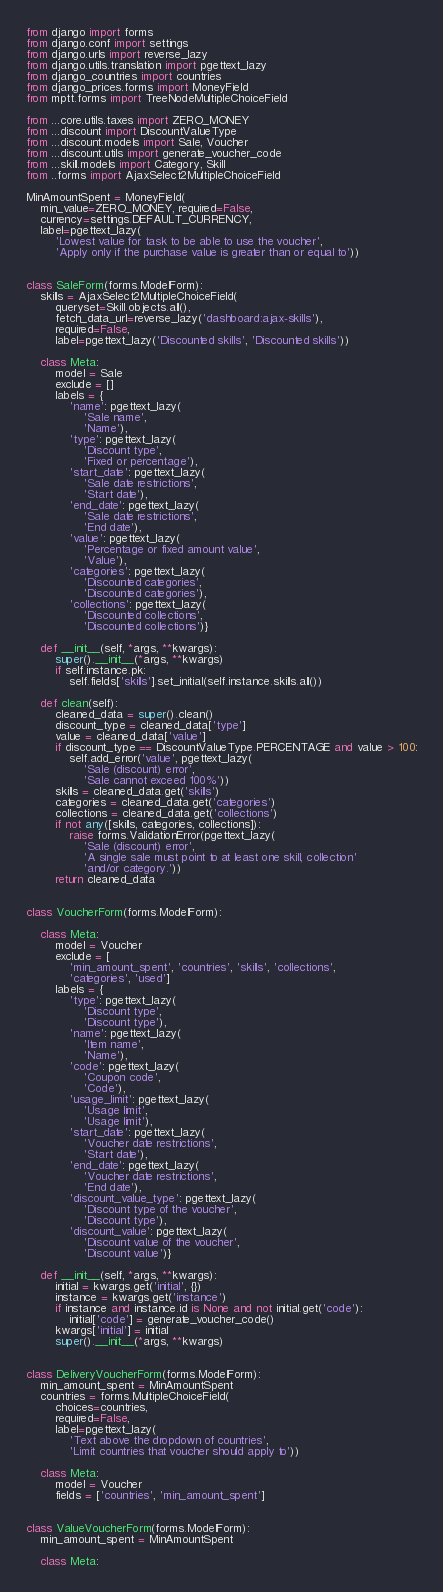Convert code to text. <code><loc_0><loc_0><loc_500><loc_500><_Python_>from django import forms
from django.conf import settings
from django.urls import reverse_lazy
from django.utils.translation import pgettext_lazy
from django_countries import countries
from django_prices.forms import MoneyField
from mptt.forms import TreeNodeMultipleChoiceField

from ...core.utils.taxes import ZERO_MONEY
from ...discount import DiscountValueType
from ...discount.models import Sale, Voucher
from ...discount.utils import generate_voucher_code
from ...skill.models import Category, Skill
from ..forms import AjaxSelect2MultipleChoiceField

MinAmountSpent = MoneyField(
    min_value=ZERO_MONEY, required=False,
    currency=settings.DEFAULT_CURRENCY,
    label=pgettext_lazy(
        'Lowest value for task to be able to use the voucher',
        'Apply only if the purchase value is greater than or equal to'))


class SaleForm(forms.ModelForm):
    skills = AjaxSelect2MultipleChoiceField(
        queryset=Skill.objects.all(),
        fetch_data_url=reverse_lazy('dashboard:ajax-skills'),
        required=False,
        label=pgettext_lazy('Discounted skills', 'Discounted skills'))

    class Meta:
        model = Sale
        exclude = []
        labels = {
            'name': pgettext_lazy(
                'Sale name',
                'Name'),
            'type': pgettext_lazy(
                'Discount type',
                'Fixed or percentage'),
            'start_date': pgettext_lazy(
                'Sale date restrictions',
                'Start date'),
            'end_date': pgettext_lazy(
                'Sale date restrictions',
                'End date'),
            'value': pgettext_lazy(
                'Percentage or fixed amount value',
                'Value'),
            'categories': pgettext_lazy(
                'Discounted categories',
                'Discounted categories'),
            'collections': pgettext_lazy(
                'Discounted collections',
                'Discounted collections')}

    def __init__(self, *args, **kwargs):
        super().__init__(*args, **kwargs)
        if self.instance.pk:
            self.fields['skills'].set_initial(self.instance.skills.all())

    def clean(self):
        cleaned_data = super().clean()
        discount_type = cleaned_data['type']
        value = cleaned_data['value']
        if discount_type == DiscountValueType.PERCENTAGE and value > 100:
            self.add_error('value', pgettext_lazy(
                'Sale (discount) error',
                'Sale cannot exceed 100%'))
        skills = cleaned_data.get('skills')
        categories = cleaned_data.get('categories')
        collections = cleaned_data.get('collections')
        if not any([skills, categories, collections]):
            raise forms.ValidationError(pgettext_lazy(
                'Sale (discount) error',
                'A single sale must point to at least one skill, collection'
                'and/or category.'))
        return cleaned_data


class VoucherForm(forms.ModelForm):

    class Meta:
        model = Voucher
        exclude = [
            'min_amount_spent', 'countries', 'skills', 'collections',
            'categories', 'used']
        labels = {
            'type': pgettext_lazy(
                'Discount type',
                'Discount type'),
            'name': pgettext_lazy(
                'Item name',
                'Name'),
            'code': pgettext_lazy(
                'Coupon code',
                'Code'),
            'usage_limit': pgettext_lazy(
                'Usage limit',
                'Usage limit'),
            'start_date': pgettext_lazy(
                'Voucher date restrictions',
                'Start date'),
            'end_date': pgettext_lazy(
                'Voucher date restrictions',
                'End date'),
            'discount_value_type': pgettext_lazy(
                'Discount type of the voucher',
                'Discount type'),
            'discount_value': pgettext_lazy(
                'Discount value of the voucher',
                'Discount value')}

    def __init__(self, *args, **kwargs):
        initial = kwargs.get('initial', {})
        instance = kwargs.get('instance')
        if instance and instance.id is None and not initial.get('code'):
            initial['code'] = generate_voucher_code()
        kwargs['initial'] = initial
        super().__init__(*args, **kwargs)


class DeliveryVoucherForm(forms.ModelForm):
    min_amount_spent = MinAmountSpent
    countries = forms.MultipleChoiceField(
        choices=countries,
        required=False,
        label=pgettext_lazy(
            'Text above the dropdown of countries',
            'Limit countries that voucher should apply to'))

    class Meta:
        model = Voucher
        fields = ['countries', 'min_amount_spent']


class ValueVoucherForm(forms.ModelForm):
    min_amount_spent = MinAmountSpent

    class Meta:</code> 